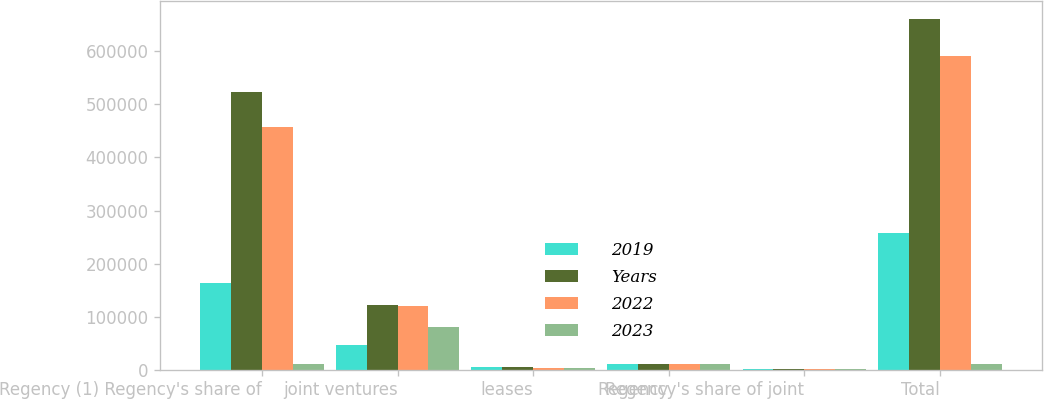Convert chart to OTSL. <chart><loc_0><loc_0><loc_500><loc_500><stacked_bar_chart><ecel><fcel>Regency (1) Regency's share of<fcel>joint ventures<fcel>leases<fcel>Regency<fcel>Regency's share of joint<fcel>Total<nl><fcel>2019<fcel>163223<fcel>46303<fcel>4982<fcel>10672<fcel>393<fcel>258034<nl><fcel>Years<fcel>523669<fcel>122512<fcel>4908<fcel>10439<fcel>394<fcel>661308<nl><fcel>2022<fcel>457680<fcel>119233<fcel>3858<fcel>10344<fcel>394<fcel>591200<nl><fcel>2023<fcel>10555.5<fcel>80113<fcel>2893<fcel>10258<fcel>394<fcel>10555.5<nl></chart> 